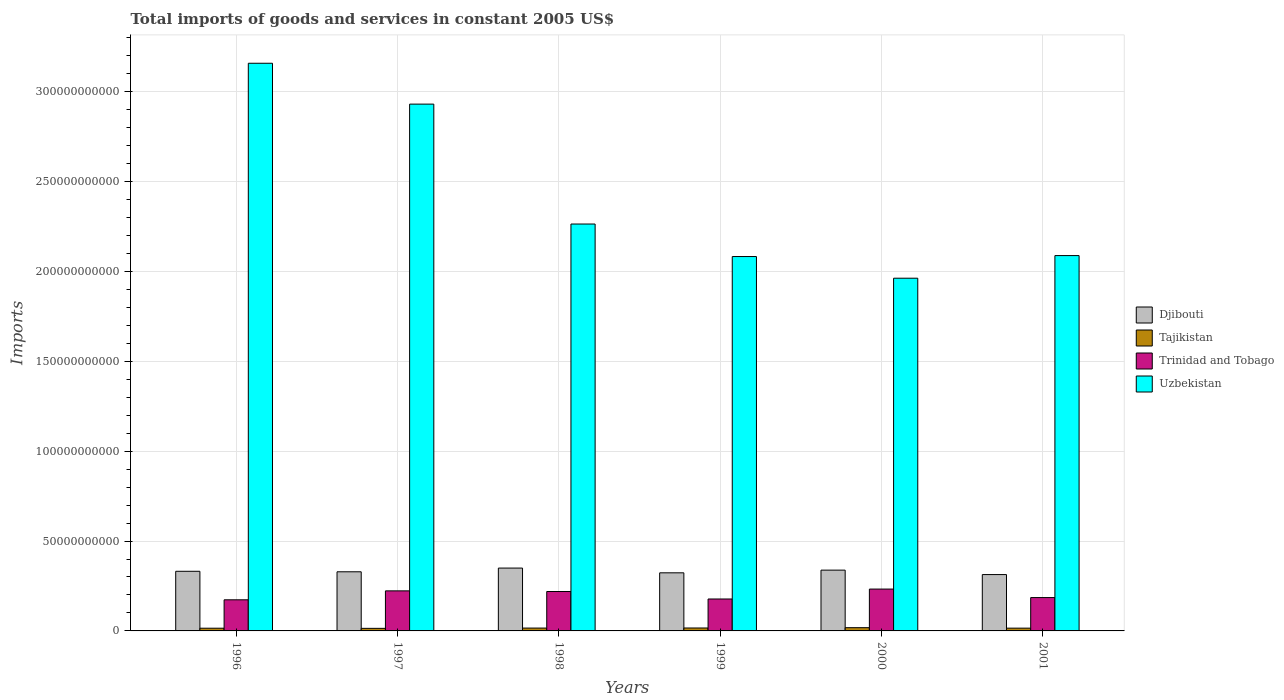How many different coloured bars are there?
Your response must be concise. 4. How many groups of bars are there?
Your answer should be very brief. 6. What is the label of the 6th group of bars from the left?
Your answer should be very brief. 2001. In how many cases, is the number of bars for a given year not equal to the number of legend labels?
Keep it short and to the point. 0. What is the total imports of goods and services in Trinidad and Tobago in 1997?
Your answer should be very brief. 2.23e+1. Across all years, what is the maximum total imports of goods and services in Trinidad and Tobago?
Provide a short and direct response. 2.33e+1. Across all years, what is the minimum total imports of goods and services in Uzbekistan?
Your response must be concise. 1.96e+11. In which year was the total imports of goods and services in Uzbekistan maximum?
Your answer should be compact. 1996. In which year was the total imports of goods and services in Trinidad and Tobago minimum?
Your answer should be very brief. 1996. What is the total total imports of goods and services in Djibouti in the graph?
Keep it short and to the point. 1.99e+11. What is the difference between the total imports of goods and services in Djibouti in 1997 and that in 1999?
Your response must be concise. 5.70e+08. What is the difference between the total imports of goods and services in Uzbekistan in 1999 and the total imports of goods and services in Tajikistan in 1996?
Your response must be concise. 2.07e+11. What is the average total imports of goods and services in Tajikistan per year?
Ensure brevity in your answer.  1.58e+09. In the year 2001, what is the difference between the total imports of goods and services in Trinidad and Tobago and total imports of goods and services in Tajikistan?
Provide a short and direct response. 1.70e+1. In how many years, is the total imports of goods and services in Trinidad and Tobago greater than 200000000000 US$?
Keep it short and to the point. 0. What is the ratio of the total imports of goods and services in Uzbekistan in 1997 to that in 1999?
Provide a succinct answer. 1.41. What is the difference between the highest and the second highest total imports of goods and services in Trinidad and Tobago?
Offer a very short reply. 1.00e+09. What is the difference between the highest and the lowest total imports of goods and services in Uzbekistan?
Keep it short and to the point. 1.20e+11. Is the sum of the total imports of goods and services in Djibouti in 1996 and 2000 greater than the maximum total imports of goods and services in Uzbekistan across all years?
Your answer should be compact. No. Is it the case that in every year, the sum of the total imports of goods and services in Trinidad and Tobago and total imports of goods and services in Uzbekistan is greater than the sum of total imports of goods and services in Tajikistan and total imports of goods and services in Djibouti?
Keep it short and to the point. Yes. What does the 3rd bar from the left in 1999 represents?
Give a very brief answer. Trinidad and Tobago. What does the 3rd bar from the right in 1998 represents?
Your answer should be compact. Tajikistan. Is it the case that in every year, the sum of the total imports of goods and services in Uzbekistan and total imports of goods and services in Tajikistan is greater than the total imports of goods and services in Trinidad and Tobago?
Your answer should be very brief. Yes. Are all the bars in the graph horizontal?
Offer a terse response. No. How many years are there in the graph?
Offer a very short reply. 6. Are the values on the major ticks of Y-axis written in scientific E-notation?
Offer a terse response. No. How many legend labels are there?
Provide a succinct answer. 4. How are the legend labels stacked?
Give a very brief answer. Vertical. What is the title of the graph?
Offer a terse response. Total imports of goods and services in constant 2005 US$. What is the label or title of the Y-axis?
Make the answer very short. Imports. What is the Imports in Djibouti in 1996?
Keep it short and to the point. 3.32e+1. What is the Imports of Tajikistan in 1996?
Your answer should be very brief. 1.50e+09. What is the Imports of Trinidad and Tobago in 1996?
Your answer should be compact. 1.73e+1. What is the Imports of Uzbekistan in 1996?
Keep it short and to the point. 3.16e+11. What is the Imports of Djibouti in 1997?
Offer a very short reply. 3.29e+1. What is the Imports of Tajikistan in 1997?
Provide a short and direct response. 1.43e+09. What is the Imports in Trinidad and Tobago in 1997?
Offer a very short reply. 2.23e+1. What is the Imports of Uzbekistan in 1997?
Provide a succinct answer. 2.93e+11. What is the Imports in Djibouti in 1998?
Offer a very short reply. 3.50e+1. What is the Imports of Tajikistan in 1998?
Your answer should be compact. 1.58e+09. What is the Imports of Trinidad and Tobago in 1998?
Your answer should be very brief. 2.19e+1. What is the Imports of Uzbekistan in 1998?
Provide a succinct answer. 2.26e+11. What is the Imports of Djibouti in 1999?
Your answer should be very brief. 3.23e+1. What is the Imports of Tajikistan in 1999?
Make the answer very short. 1.63e+09. What is the Imports in Trinidad and Tobago in 1999?
Make the answer very short. 1.78e+1. What is the Imports in Uzbekistan in 1999?
Provide a succinct answer. 2.08e+11. What is the Imports in Djibouti in 2000?
Keep it short and to the point. 3.38e+1. What is the Imports of Tajikistan in 2000?
Your response must be concise. 1.80e+09. What is the Imports of Trinidad and Tobago in 2000?
Your answer should be compact. 2.33e+1. What is the Imports in Uzbekistan in 2000?
Provide a succinct answer. 1.96e+11. What is the Imports of Djibouti in 2001?
Make the answer very short. 3.14e+1. What is the Imports of Tajikistan in 2001?
Provide a short and direct response. 1.54e+09. What is the Imports in Trinidad and Tobago in 2001?
Keep it short and to the point. 1.86e+1. What is the Imports of Uzbekistan in 2001?
Your answer should be compact. 2.09e+11. Across all years, what is the maximum Imports in Djibouti?
Your answer should be compact. 3.50e+1. Across all years, what is the maximum Imports in Tajikistan?
Offer a terse response. 1.80e+09. Across all years, what is the maximum Imports of Trinidad and Tobago?
Your answer should be compact. 2.33e+1. Across all years, what is the maximum Imports in Uzbekistan?
Provide a short and direct response. 3.16e+11. Across all years, what is the minimum Imports in Djibouti?
Keep it short and to the point. 3.14e+1. Across all years, what is the minimum Imports of Tajikistan?
Your answer should be compact. 1.43e+09. Across all years, what is the minimum Imports in Trinidad and Tobago?
Ensure brevity in your answer.  1.73e+1. Across all years, what is the minimum Imports in Uzbekistan?
Provide a short and direct response. 1.96e+11. What is the total Imports in Djibouti in the graph?
Provide a short and direct response. 1.99e+11. What is the total Imports of Tajikistan in the graph?
Ensure brevity in your answer.  9.49e+09. What is the total Imports in Trinidad and Tobago in the graph?
Your response must be concise. 1.21e+11. What is the total Imports in Uzbekistan in the graph?
Offer a very short reply. 1.45e+12. What is the difference between the Imports of Djibouti in 1996 and that in 1997?
Ensure brevity in your answer.  2.83e+08. What is the difference between the Imports of Tajikistan in 1996 and that in 1997?
Keep it short and to the point. 7.88e+07. What is the difference between the Imports of Trinidad and Tobago in 1996 and that in 1997?
Provide a succinct answer. -4.98e+09. What is the difference between the Imports of Uzbekistan in 1996 and that in 1997?
Your answer should be very brief. 2.27e+1. What is the difference between the Imports of Djibouti in 1996 and that in 1998?
Your answer should be very brief. -1.79e+09. What is the difference between the Imports in Tajikistan in 1996 and that in 1998?
Your answer should be very brief. -7.95e+07. What is the difference between the Imports in Trinidad and Tobago in 1996 and that in 1998?
Provide a short and direct response. -4.62e+09. What is the difference between the Imports in Uzbekistan in 1996 and that in 1998?
Ensure brevity in your answer.  8.94e+1. What is the difference between the Imports of Djibouti in 1996 and that in 1999?
Your answer should be compact. 8.53e+08. What is the difference between the Imports in Tajikistan in 1996 and that in 1999?
Your response must be concise. -1.28e+08. What is the difference between the Imports of Trinidad and Tobago in 1996 and that in 1999?
Give a very brief answer. -4.57e+08. What is the difference between the Imports of Uzbekistan in 1996 and that in 1999?
Offer a terse response. 1.08e+11. What is the difference between the Imports in Djibouti in 1996 and that in 2000?
Provide a short and direct response. -6.41e+08. What is the difference between the Imports of Tajikistan in 1996 and that in 2000?
Offer a terse response. -2.98e+08. What is the difference between the Imports of Trinidad and Tobago in 1996 and that in 2000?
Make the answer very short. -5.98e+09. What is the difference between the Imports in Uzbekistan in 1996 and that in 2000?
Ensure brevity in your answer.  1.20e+11. What is the difference between the Imports in Djibouti in 1996 and that in 2001?
Provide a succinct answer. 1.82e+09. What is the difference between the Imports of Tajikistan in 1996 and that in 2001?
Make the answer very short. -3.68e+07. What is the difference between the Imports of Trinidad and Tobago in 1996 and that in 2001?
Your response must be concise. -1.25e+09. What is the difference between the Imports of Uzbekistan in 1996 and that in 2001?
Offer a very short reply. 1.07e+11. What is the difference between the Imports of Djibouti in 1997 and that in 1998?
Offer a terse response. -2.08e+09. What is the difference between the Imports of Tajikistan in 1997 and that in 1998?
Offer a terse response. -1.58e+08. What is the difference between the Imports in Trinidad and Tobago in 1997 and that in 1998?
Provide a succinct answer. 3.59e+08. What is the difference between the Imports in Uzbekistan in 1997 and that in 1998?
Your response must be concise. 6.67e+1. What is the difference between the Imports of Djibouti in 1997 and that in 1999?
Make the answer very short. 5.70e+08. What is the difference between the Imports in Tajikistan in 1997 and that in 1999?
Your response must be concise. -2.07e+08. What is the difference between the Imports in Trinidad and Tobago in 1997 and that in 1999?
Your answer should be compact. 4.52e+09. What is the difference between the Imports of Uzbekistan in 1997 and that in 1999?
Ensure brevity in your answer.  8.48e+1. What is the difference between the Imports in Djibouti in 1997 and that in 2000?
Your response must be concise. -9.24e+08. What is the difference between the Imports of Tajikistan in 1997 and that in 2000?
Your answer should be compact. -3.77e+08. What is the difference between the Imports in Trinidad and Tobago in 1997 and that in 2000?
Offer a terse response. -1.00e+09. What is the difference between the Imports in Uzbekistan in 1997 and that in 2000?
Your answer should be very brief. 9.69e+1. What is the difference between the Imports of Djibouti in 1997 and that in 2001?
Make the answer very short. 1.54e+09. What is the difference between the Imports in Tajikistan in 1997 and that in 2001?
Make the answer very short. -1.16e+08. What is the difference between the Imports in Trinidad and Tobago in 1997 and that in 2001?
Make the answer very short. 3.73e+09. What is the difference between the Imports in Uzbekistan in 1997 and that in 2001?
Your answer should be very brief. 8.43e+1. What is the difference between the Imports in Djibouti in 1998 and that in 1999?
Provide a short and direct response. 2.65e+09. What is the difference between the Imports of Tajikistan in 1998 and that in 1999?
Your answer should be very brief. -4.87e+07. What is the difference between the Imports in Trinidad and Tobago in 1998 and that in 1999?
Offer a terse response. 4.16e+09. What is the difference between the Imports in Uzbekistan in 1998 and that in 1999?
Your answer should be very brief. 1.81e+1. What is the difference between the Imports in Djibouti in 1998 and that in 2000?
Give a very brief answer. 1.15e+09. What is the difference between the Imports in Tajikistan in 1998 and that in 2000?
Your answer should be compact. -2.19e+08. What is the difference between the Imports in Trinidad and Tobago in 1998 and that in 2000?
Ensure brevity in your answer.  -1.36e+09. What is the difference between the Imports of Uzbekistan in 1998 and that in 2000?
Your response must be concise. 3.02e+1. What is the difference between the Imports of Djibouti in 1998 and that in 2001?
Provide a succinct answer. 3.62e+09. What is the difference between the Imports in Tajikistan in 1998 and that in 2001?
Your response must be concise. 4.27e+07. What is the difference between the Imports of Trinidad and Tobago in 1998 and that in 2001?
Your answer should be compact. 3.37e+09. What is the difference between the Imports in Uzbekistan in 1998 and that in 2001?
Provide a succinct answer. 1.76e+1. What is the difference between the Imports in Djibouti in 1999 and that in 2000?
Keep it short and to the point. -1.49e+09. What is the difference between the Imports of Tajikistan in 1999 and that in 2000?
Your answer should be very brief. -1.70e+08. What is the difference between the Imports of Trinidad and Tobago in 1999 and that in 2000?
Your answer should be compact. -5.52e+09. What is the difference between the Imports in Uzbekistan in 1999 and that in 2000?
Provide a succinct answer. 1.21e+1. What is the difference between the Imports in Djibouti in 1999 and that in 2001?
Your answer should be very brief. 9.71e+08. What is the difference between the Imports of Tajikistan in 1999 and that in 2001?
Offer a very short reply. 9.14e+07. What is the difference between the Imports in Trinidad and Tobago in 1999 and that in 2001?
Offer a very short reply. -7.90e+08. What is the difference between the Imports in Uzbekistan in 1999 and that in 2001?
Make the answer very short. -5.30e+08. What is the difference between the Imports of Djibouti in 2000 and that in 2001?
Provide a succinct answer. 2.47e+09. What is the difference between the Imports of Tajikistan in 2000 and that in 2001?
Offer a very short reply. 2.61e+08. What is the difference between the Imports in Trinidad and Tobago in 2000 and that in 2001?
Your answer should be very brief. 4.73e+09. What is the difference between the Imports of Uzbekistan in 2000 and that in 2001?
Ensure brevity in your answer.  -1.26e+1. What is the difference between the Imports of Djibouti in 1996 and the Imports of Tajikistan in 1997?
Keep it short and to the point. 3.18e+1. What is the difference between the Imports in Djibouti in 1996 and the Imports in Trinidad and Tobago in 1997?
Provide a short and direct response. 1.09e+1. What is the difference between the Imports in Djibouti in 1996 and the Imports in Uzbekistan in 1997?
Your answer should be compact. -2.60e+11. What is the difference between the Imports of Tajikistan in 1996 and the Imports of Trinidad and Tobago in 1997?
Provide a succinct answer. -2.08e+1. What is the difference between the Imports in Tajikistan in 1996 and the Imports in Uzbekistan in 1997?
Give a very brief answer. -2.92e+11. What is the difference between the Imports of Trinidad and Tobago in 1996 and the Imports of Uzbekistan in 1997?
Your answer should be very brief. -2.76e+11. What is the difference between the Imports in Djibouti in 1996 and the Imports in Tajikistan in 1998?
Your answer should be compact. 3.16e+1. What is the difference between the Imports of Djibouti in 1996 and the Imports of Trinidad and Tobago in 1998?
Your response must be concise. 1.13e+1. What is the difference between the Imports of Djibouti in 1996 and the Imports of Uzbekistan in 1998?
Provide a succinct answer. -1.93e+11. What is the difference between the Imports in Tajikistan in 1996 and the Imports in Trinidad and Tobago in 1998?
Ensure brevity in your answer.  -2.04e+1. What is the difference between the Imports of Tajikistan in 1996 and the Imports of Uzbekistan in 1998?
Provide a short and direct response. -2.25e+11. What is the difference between the Imports in Trinidad and Tobago in 1996 and the Imports in Uzbekistan in 1998?
Provide a succinct answer. -2.09e+11. What is the difference between the Imports of Djibouti in 1996 and the Imports of Tajikistan in 1999?
Your response must be concise. 3.15e+1. What is the difference between the Imports of Djibouti in 1996 and the Imports of Trinidad and Tobago in 1999?
Make the answer very short. 1.54e+1. What is the difference between the Imports of Djibouti in 1996 and the Imports of Uzbekistan in 1999?
Your answer should be compact. -1.75e+11. What is the difference between the Imports of Tajikistan in 1996 and the Imports of Trinidad and Tobago in 1999?
Give a very brief answer. -1.63e+1. What is the difference between the Imports of Tajikistan in 1996 and the Imports of Uzbekistan in 1999?
Offer a terse response. -2.07e+11. What is the difference between the Imports of Trinidad and Tobago in 1996 and the Imports of Uzbekistan in 1999?
Offer a very short reply. -1.91e+11. What is the difference between the Imports in Djibouti in 1996 and the Imports in Tajikistan in 2000?
Your answer should be compact. 3.14e+1. What is the difference between the Imports of Djibouti in 1996 and the Imports of Trinidad and Tobago in 2000?
Provide a succinct answer. 9.89e+09. What is the difference between the Imports of Djibouti in 1996 and the Imports of Uzbekistan in 2000?
Your response must be concise. -1.63e+11. What is the difference between the Imports in Tajikistan in 1996 and the Imports in Trinidad and Tobago in 2000?
Your response must be concise. -2.18e+1. What is the difference between the Imports of Tajikistan in 1996 and the Imports of Uzbekistan in 2000?
Offer a very short reply. -1.95e+11. What is the difference between the Imports in Trinidad and Tobago in 1996 and the Imports in Uzbekistan in 2000?
Keep it short and to the point. -1.79e+11. What is the difference between the Imports of Djibouti in 1996 and the Imports of Tajikistan in 2001?
Provide a succinct answer. 3.16e+1. What is the difference between the Imports of Djibouti in 1996 and the Imports of Trinidad and Tobago in 2001?
Provide a short and direct response. 1.46e+1. What is the difference between the Imports of Djibouti in 1996 and the Imports of Uzbekistan in 2001?
Ensure brevity in your answer.  -1.76e+11. What is the difference between the Imports of Tajikistan in 1996 and the Imports of Trinidad and Tobago in 2001?
Your answer should be compact. -1.71e+1. What is the difference between the Imports in Tajikistan in 1996 and the Imports in Uzbekistan in 2001?
Ensure brevity in your answer.  -2.07e+11. What is the difference between the Imports in Trinidad and Tobago in 1996 and the Imports in Uzbekistan in 2001?
Make the answer very short. -1.92e+11. What is the difference between the Imports in Djibouti in 1997 and the Imports in Tajikistan in 1998?
Ensure brevity in your answer.  3.13e+1. What is the difference between the Imports of Djibouti in 1997 and the Imports of Trinidad and Tobago in 1998?
Your answer should be compact. 1.10e+1. What is the difference between the Imports in Djibouti in 1997 and the Imports in Uzbekistan in 1998?
Give a very brief answer. -1.93e+11. What is the difference between the Imports of Tajikistan in 1997 and the Imports of Trinidad and Tobago in 1998?
Ensure brevity in your answer.  -2.05e+1. What is the difference between the Imports of Tajikistan in 1997 and the Imports of Uzbekistan in 1998?
Keep it short and to the point. -2.25e+11. What is the difference between the Imports of Trinidad and Tobago in 1997 and the Imports of Uzbekistan in 1998?
Provide a short and direct response. -2.04e+11. What is the difference between the Imports in Djibouti in 1997 and the Imports in Tajikistan in 1999?
Your response must be concise. 3.13e+1. What is the difference between the Imports of Djibouti in 1997 and the Imports of Trinidad and Tobago in 1999?
Make the answer very short. 1.51e+1. What is the difference between the Imports of Djibouti in 1997 and the Imports of Uzbekistan in 1999?
Offer a very short reply. -1.75e+11. What is the difference between the Imports in Tajikistan in 1997 and the Imports in Trinidad and Tobago in 1999?
Your answer should be very brief. -1.63e+1. What is the difference between the Imports of Tajikistan in 1997 and the Imports of Uzbekistan in 1999?
Provide a short and direct response. -2.07e+11. What is the difference between the Imports in Trinidad and Tobago in 1997 and the Imports in Uzbekistan in 1999?
Offer a very short reply. -1.86e+11. What is the difference between the Imports in Djibouti in 1997 and the Imports in Tajikistan in 2000?
Offer a very short reply. 3.11e+1. What is the difference between the Imports of Djibouti in 1997 and the Imports of Trinidad and Tobago in 2000?
Offer a terse response. 9.61e+09. What is the difference between the Imports in Djibouti in 1997 and the Imports in Uzbekistan in 2000?
Ensure brevity in your answer.  -1.63e+11. What is the difference between the Imports of Tajikistan in 1997 and the Imports of Trinidad and Tobago in 2000?
Your answer should be very brief. -2.19e+1. What is the difference between the Imports of Tajikistan in 1997 and the Imports of Uzbekistan in 2000?
Give a very brief answer. -1.95e+11. What is the difference between the Imports in Trinidad and Tobago in 1997 and the Imports in Uzbekistan in 2000?
Offer a very short reply. -1.74e+11. What is the difference between the Imports of Djibouti in 1997 and the Imports of Tajikistan in 2001?
Your answer should be compact. 3.14e+1. What is the difference between the Imports in Djibouti in 1997 and the Imports in Trinidad and Tobago in 2001?
Offer a terse response. 1.43e+1. What is the difference between the Imports of Djibouti in 1997 and the Imports of Uzbekistan in 2001?
Make the answer very short. -1.76e+11. What is the difference between the Imports in Tajikistan in 1997 and the Imports in Trinidad and Tobago in 2001?
Your answer should be very brief. -1.71e+1. What is the difference between the Imports of Tajikistan in 1997 and the Imports of Uzbekistan in 2001?
Provide a short and direct response. -2.07e+11. What is the difference between the Imports in Trinidad and Tobago in 1997 and the Imports in Uzbekistan in 2001?
Your response must be concise. -1.87e+11. What is the difference between the Imports of Djibouti in 1998 and the Imports of Tajikistan in 1999?
Provide a succinct answer. 3.33e+1. What is the difference between the Imports of Djibouti in 1998 and the Imports of Trinidad and Tobago in 1999?
Your answer should be compact. 1.72e+1. What is the difference between the Imports of Djibouti in 1998 and the Imports of Uzbekistan in 1999?
Provide a succinct answer. -1.73e+11. What is the difference between the Imports in Tajikistan in 1998 and the Imports in Trinidad and Tobago in 1999?
Your answer should be very brief. -1.62e+1. What is the difference between the Imports in Tajikistan in 1998 and the Imports in Uzbekistan in 1999?
Offer a very short reply. -2.07e+11. What is the difference between the Imports of Trinidad and Tobago in 1998 and the Imports of Uzbekistan in 1999?
Offer a terse response. -1.86e+11. What is the difference between the Imports of Djibouti in 1998 and the Imports of Tajikistan in 2000?
Offer a terse response. 3.32e+1. What is the difference between the Imports in Djibouti in 1998 and the Imports in Trinidad and Tobago in 2000?
Provide a succinct answer. 1.17e+1. What is the difference between the Imports in Djibouti in 1998 and the Imports in Uzbekistan in 2000?
Your answer should be very brief. -1.61e+11. What is the difference between the Imports in Tajikistan in 1998 and the Imports in Trinidad and Tobago in 2000?
Provide a short and direct response. -2.17e+1. What is the difference between the Imports in Tajikistan in 1998 and the Imports in Uzbekistan in 2000?
Offer a very short reply. -1.95e+11. What is the difference between the Imports in Trinidad and Tobago in 1998 and the Imports in Uzbekistan in 2000?
Your response must be concise. -1.74e+11. What is the difference between the Imports in Djibouti in 1998 and the Imports in Tajikistan in 2001?
Your response must be concise. 3.34e+1. What is the difference between the Imports in Djibouti in 1998 and the Imports in Trinidad and Tobago in 2001?
Provide a short and direct response. 1.64e+1. What is the difference between the Imports in Djibouti in 1998 and the Imports in Uzbekistan in 2001?
Make the answer very short. -1.74e+11. What is the difference between the Imports in Tajikistan in 1998 and the Imports in Trinidad and Tobago in 2001?
Your response must be concise. -1.70e+1. What is the difference between the Imports in Tajikistan in 1998 and the Imports in Uzbekistan in 2001?
Your response must be concise. -2.07e+11. What is the difference between the Imports in Trinidad and Tobago in 1998 and the Imports in Uzbekistan in 2001?
Ensure brevity in your answer.  -1.87e+11. What is the difference between the Imports in Djibouti in 1999 and the Imports in Tajikistan in 2000?
Your response must be concise. 3.05e+1. What is the difference between the Imports in Djibouti in 1999 and the Imports in Trinidad and Tobago in 2000?
Provide a short and direct response. 9.04e+09. What is the difference between the Imports of Djibouti in 1999 and the Imports of Uzbekistan in 2000?
Offer a very short reply. -1.64e+11. What is the difference between the Imports in Tajikistan in 1999 and the Imports in Trinidad and Tobago in 2000?
Provide a short and direct response. -2.17e+1. What is the difference between the Imports in Tajikistan in 1999 and the Imports in Uzbekistan in 2000?
Keep it short and to the point. -1.95e+11. What is the difference between the Imports of Trinidad and Tobago in 1999 and the Imports of Uzbekistan in 2000?
Keep it short and to the point. -1.78e+11. What is the difference between the Imports in Djibouti in 1999 and the Imports in Tajikistan in 2001?
Your answer should be very brief. 3.08e+1. What is the difference between the Imports of Djibouti in 1999 and the Imports of Trinidad and Tobago in 2001?
Give a very brief answer. 1.38e+1. What is the difference between the Imports in Djibouti in 1999 and the Imports in Uzbekistan in 2001?
Provide a succinct answer. -1.76e+11. What is the difference between the Imports in Tajikistan in 1999 and the Imports in Trinidad and Tobago in 2001?
Your answer should be compact. -1.69e+1. What is the difference between the Imports in Tajikistan in 1999 and the Imports in Uzbekistan in 2001?
Your response must be concise. -2.07e+11. What is the difference between the Imports in Trinidad and Tobago in 1999 and the Imports in Uzbekistan in 2001?
Keep it short and to the point. -1.91e+11. What is the difference between the Imports of Djibouti in 2000 and the Imports of Tajikistan in 2001?
Make the answer very short. 3.23e+1. What is the difference between the Imports in Djibouti in 2000 and the Imports in Trinidad and Tobago in 2001?
Make the answer very short. 1.53e+1. What is the difference between the Imports of Djibouti in 2000 and the Imports of Uzbekistan in 2001?
Give a very brief answer. -1.75e+11. What is the difference between the Imports in Tajikistan in 2000 and the Imports in Trinidad and Tobago in 2001?
Provide a short and direct response. -1.68e+1. What is the difference between the Imports in Tajikistan in 2000 and the Imports in Uzbekistan in 2001?
Your response must be concise. -2.07e+11. What is the difference between the Imports of Trinidad and Tobago in 2000 and the Imports of Uzbekistan in 2001?
Provide a short and direct response. -1.86e+11. What is the average Imports of Djibouti per year?
Your response must be concise. 3.31e+1. What is the average Imports in Tajikistan per year?
Provide a succinct answer. 1.58e+09. What is the average Imports of Trinidad and Tobago per year?
Keep it short and to the point. 2.02e+1. What is the average Imports in Uzbekistan per year?
Keep it short and to the point. 2.41e+11. In the year 1996, what is the difference between the Imports in Djibouti and Imports in Tajikistan?
Offer a very short reply. 3.17e+1. In the year 1996, what is the difference between the Imports in Djibouti and Imports in Trinidad and Tobago?
Your answer should be very brief. 1.59e+1. In the year 1996, what is the difference between the Imports in Djibouti and Imports in Uzbekistan?
Offer a terse response. -2.83e+11. In the year 1996, what is the difference between the Imports of Tajikistan and Imports of Trinidad and Tobago?
Your answer should be compact. -1.58e+1. In the year 1996, what is the difference between the Imports of Tajikistan and Imports of Uzbekistan?
Offer a very short reply. -3.14e+11. In the year 1996, what is the difference between the Imports of Trinidad and Tobago and Imports of Uzbekistan?
Provide a succinct answer. -2.99e+11. In the year 1997, what is the difference between the Imports of Djibouti and Imports of Tajikistan?
Provide a succinct answer. 3.15e+1. In the year 1997, what is the difference between the Imports of Djibouti and Imports of Trinidad and Tobago?
Provide a succinct answer. 1.06e+1. In the year 1997, what is the difference between the Imports of Djibouti and Imports of Uzbekistan?
Offer a very short reply. -2.60e+11. In the year 1997, what is the difference between the Imports in Tajikistan and Imports in Trinidad and Tobago?
Offer a very short reply. -2.09e+1. In the year 1997, what is the difference between the Imports in Tajikistan and Imports in Uzbekistan?
Your answer should be very brief. -2.92e+11. In the year 1997, what is the difference between the Imports of Trinidad and Tobago and Imports of Uzbekistan?
Your answer should be very brief. -2.71e+11. In the year 1998, what is the difference between the Imports of Djibouti and Imports of Tajikistan?
Provide a short and direct response. 3.34e+1. In the year 1998, what is the difference between the Imports in Djibouti and Imports in Trinidad and Tobago?
Give a very brief answer. 1.30e+1. In the year 1998, what is the difference between the Imports in Djibouti and Imports in Uzbekistan?
Make the answer very short. -1.91e+11. In the year 1998, what is the difference between the Imports of Tajikistan and Imports of Trinidad and Tobago?
Keep it short and to the point. -2.03e+1. In the year 1998, what is the difference between the Imports of Tajikistan and Imports of Uzbekistan?
Provide a short and direct response. -2.25e+11. In the year 1998, what is the difference between the Imports in Trinidad and Tobago and Imports in Uzbekistan?
Keep it short and to the point. -2.04e+11. In the year 1999, what is the difference between the Imports in Djibouti and Imports in Tajikistan?
Offer a very short reply. 3.07e+1. In the year 1999, what is the difference between the Imports of Djibouti and Imports of Trinidad and Tobago?
Ensure brevity in your answer.  1.46e+1. In the year 1999, what is the difference between the Imports in Djibouti and Imports in Uzbekistan?
Keep it short and to the point. -1.76e+11. In the year 1999, what is the difference between the Imports in Tajikistan and Imports in Trinidad and Tobago?
Provide a succinct answer. -1.61e+1. In the year 1999, what is the difference between the Imports of Tajikistan and Imports of Uzbekistan?
Offer a terse response. -2.07e+11. In the year 1999, what is the difference between the Imports in Trinidad and Tobago and Imports in Uzbekistan?
Offer a very short reply. -1.91e+11. In the year 2000, what is the difference between the Imports of Djibouti and Imports of Tajikistan?
Ensure brevity in your answer.  3.20e+1. In the year 2000, what is the difference between the Imports of Djibouti and Imports of Trinidad and Tobago?
Give a very brief answer. 1.05e+1. In the year 2000, what is the difference between the Imports of Djibouti and Imports of Uzbekistan?
Offer a terse response. -1.62e+11. In the year 2000, what is the difference between the Imports of Tajikistan and Imports of Trinidad and Tobago?
Provide a succinct answer. -2.15e+1. In the year 2000, what is the difference between the Imports in Tajikistan and Imports in Uzbekistan?
Keep it short and to the point. -1.94e+11. In the year 2000, what is the difference between the Imports of Trinidad and Tobago and Imports of Uzbekistan?
Your answer should be very brief. -1.73e+11. In the year 2001, what is the difference between the Imports in Djibouti and Imports in Tajikistan?
Your answer should be very brief. 2.98e+1. In the year 2001, what is the difference between the Imports in Djibouti and Imports in Trinidad and Tobago?
Give a very brief answer. 1.28e+1. In the year 2001, what is the difference between the Imports of Djibouti and Imports of Uzbekistan?
Provide a short and direct response. -1.77e+11. In the year 2001, what is the difference between the Imports in Tajikistan and Imports in Trinidad and Tobago?
Provide a short and direct response. -1.70e+1. In the year 2001, what is the difference between the Imports of Tajikistan and Imports of Uzbekistan?
Your response must be concise. -2.07e+11. In the year 2001, what is the difference between the Imports of Trinidad and Tobago and Imports of Uzbekistan?
Your response must be concise. -1.90e+11. What is the ratio of the Imports in Djibouti in 1996 to that in 1997?
Give a very brief answer. 1.01. What is the ratio of the Imports of Tajikistan in 1996 to that in 1997?
Make the answer very short. 1.06. What is the ratio of the Imports of Trinidad and Tobago in 1996 to that in 1997?
Your answer should be compact. 0.78. What is the ratio of the Imports of Uzbekistan in 1996 to that in 1997?
Offer a terse response. 1.08. What is the ratio of the Imports in Djibouti in 1996 to that in 1998?
Provide a short and direct response. 0.95. What is the ratio of the Imports of Tajikistan in 1996 to that in 1998?
Give a very brief answer. 0.95. What is the ratio of the Imports of Trinidad and Tobago in 1996 to that in 1998?
Provide a succinct answer. 0.79. What is the ratio of the Imports of Uzbekistan in 1996 to that in 1998?
Make the answer very short. 1.4. What is the ratio of the Imports of Djibouti in 1996 to that in 1999?
Your answer should be compact. 1.03. What is the ratio of the Imports in Tajikistan in 1996 to that in 1999?
Your answer should be compact. 0.92. What is the ratio of the Imports of Trinidad and Tobago in 1996 to that in 1999?
Offer a very short reply. 0.97. What is the ratio of the Imports of Uzbekistan in 1996 to that in 1999?
Ensure brevity in your answer.  1.52. What is the ratio of the Imports of Tajikistan in 1996 to that in 2000?
Keep it short and to the point. 0.83. What is the ratio of the Imports in Trinidad and Tobago in 1996 to that in 2000?
Give a very brief answer. 0.74. What is the ratio of the Imports of Uzbekistan in 1996 to that in 2000?
Give a very brief answer. 1.61. What is the ratio of the Imports in Djibouti in 1996 to that in 2001?
Give a very brief answer. 1.06. What is the ratio of the Imports of Tajikistan in 1996 to that in 2001?
Give a very brief answer. 0.98. What is the ratio of the Imports of Trinidad and Tobago in 1996 to that in 2001?
Ensure brevity in your answer.  0.93. What is the ratio of the Imports in Uzbekistan in 1996 to that in 2001?
Keep it short and to the point. 1.51. What is the ratio of the Imports of Djibouti in 1997 to that in 1998?
Provide a succinct answer. 0.94. What is the ratio of the Imports in Tajikistan in 1997 to that in 1998?
Provide a succinct answer. 0.9. What is the ratio of the Imports of Trinidad and Tobago in 1997 to that in 1998?
Offer a terse response. 1.02. What is the ratio of the Imports of Uzbekistan in 1997 to that in 1998?
Provide a short and direct response. 1.29. What is the ratio of the Imports in Djibouti in 1997 to that in 1999?
Your answer should be very brief. 1.02. What is the ratio of the Imports in Tajikistan in 1997 to that in 1999?
Keep it short and to the point. 0.87. What is the ratio of the Imports of Trinidad and Tobago in 1997 to that in 1999?
Ensure brevity in your answer.  1.25. What is the ratio of the Imports in Uzbekistan in 1997 to that in 1999?
Give a very brief answer. 1.41. What is the ratio of the Imports in Djibouti in 1997 to that in 2000?
Offer a very short reply. 0.97. What is the ratio of the Imports of Tajikistan in 1997 to that in 2000?
Your response must be concise. 0.79. What is the ratio of the Imports in Uzbekistan in 1997 to that in 2000?
Offer a terse response. 1.49. What is the ratio of the Imports in Djibouti in 1997 to that in 2001?
Ensure brevity in your answer.  1.05. What is the ratio of the Imports in Tajikistan in 1997 to that in 2001?
Provide a short and direct response. 0.93. What is the ratio of the Imports in Trinidad and Tobago in 1997 to that in 2001?
Your answer should be very brief. 1.2. What is the ratio of the Imports of Uzbekistan in 1997 to that in 2001?
Your answer should be very brief. 1.4. What is the ratio of the Imports of Djibouti in 1998 to that in 1999?
Keep it short and to the point. 1.08. What is the ratio of the Imports in Tajikistan in 1998 to that in 1999?
Offer a very short reply. 0.97. What is the ratio of the Imports of Trinidad and Tobago in 1998 to that in 1999?
Give a very brief answer. 1.23. What is the ratio of the Imports in Uzbekistan in 1998 to that in 1999?
Give a very brief answer. 1.09. What is the ratio of the Imports of Djibouti in 1998 to that in 2000?
Your answer should be very brief. 1.03. What is the ratio of the Imports in Tajikistan in 1998 to that in 2000?
Make the answer very short. 0.88. What is the ratio of the Imports in Trinidad and Tobago in 1998 to that in 2000?
Make the answer very short. 0.94. What is the ratio of the Imports in Uzbekistan in 1998 to that in 2000?
Offer a terse response. 1.15. What is the ratio of the Imports in Djibouti in 1998 to that in 2001?
Your response must be concise. 1.12. What is the ratio of the Imports of Tajikistan in 1998 to that in 2001?
Your answer should be very brief. 1.03. What is the ratio of the Imports in Trinidad and Tobago in 1998 to that in 2001?
Make the answer very short. 1.18. What is the ratio of the Imports in Uzbekistan in 1998 to that in 2001?
Keep it short and to the point. 1.08. What is the ratio of the Imports of Djibouti in 1999 to that in 2000?
Ensure brevity in your answer.  0.96. What is the ratio of the Imports of Tajikistan in 1999 to that in 2000?
Give a very brief answer. 0.91. What is the ratio of the Imports in Trinidad and Tobago in 1999 to that in 2000?
Make the answer very short. 0.76. What is the ratio of the Imports of Uzbekistan in 1999 to that in 2000?
Provide a short and direct response. 1.06. What is the ratio of the Imports of Djibouti in 1999 to that in 2001?
Your response must be concise. 1.03. What is the ratio of the Imports of Tajikistan in 1999 to that in 2001?
Offer a very short reply. 1.06. What is the ratio of the Imports of Trinidad and Tobago in 1999 to that in 2001?
Provide a short and direct response. 0.96. What is the ratio of the Imports of Uzbekistan in 1999 to that in 2001?
Keep it short and to the point. 1. What is the ratio of the Imports of Djibouti in 2000 to that in 2001?
Your response must be concise. 1.08. What is the ratio of the Imports in Tajikistan in 2000 to that in 2001?
Offer a very short reply. 1.17. What is the ratio of the Imports in Trinidad and Tobago in 2000 to that in 2001?
Your answer should be very brief. 1.25. What is the ratio of the Imports of Uzbekistan in 2000 to that in 2001?
Ensure brevity in your answer.  0.94. What is the difference between the highest and the second highest Imports of Djibouti?
Keep it short and to the point. 1.15e+09. What is the difference between the highest and the second highest Imports of Tajikistan?
Your response must be concise. 1.70e+08. What is the difference between the highest and the second highest Imports in Trinidad and Tobago?
Your answer should be very brief. 1.00e+09. What is the difference between the highest and the second highest Imports in Uzbekistan?
Keep it short and to the point. 2.27e+1. What is the difference between the highest and the lowest Imports in Djibouti?
Give a very brief answer. 3.62e+09. What is the difference between the highest and the lowest Imports in Tajikistan?
Keep it short and to the point. 3.77e+08. What is the difference between the highest and the lowest Imports in Trinidad and Tobago?
Give a very brief answer. 5.98e+09. What is the difference between the highest and the lowest Imports of Uzbekistan?
Keep it short and to the point. 1.20e+11. 